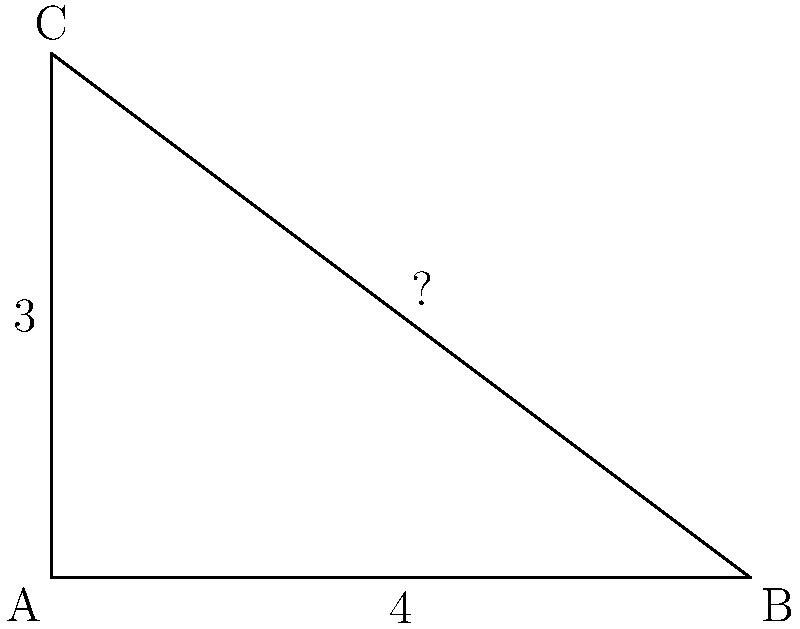In a mock interview scenario, you're discussing problem-solving skills with a job seeker. You present them with a right-angled triangle ABC, where the length of side AB is 4 units and the length of side AC is 3 units. How would you guide them to calculate the length of the hypotenuse BC using the Pythagorean theorem? To find the length of the hypotenuse BC, we can guide the job seeker through the following steps:

1. Identify the Pythagorean theorem: $a^2 + b^2 = c^2$, where $c$ is the hypotenuse and $a$ and $b$ are the other two sides.

2. Assign the known values:
   $a = 3$ (length of AC)
   $b = 4$ (length of AB)
   $c = $ unknown (length of BC, the hypotenuse)

3. Substitute these values into the Pythagorean theorem:
   $3^2 + 4^2 = c^2$

4. Calculate the squares:
   $9 + 16 = c^2$

5. Add the left side:
   $25 = c^2$

6. Take the square root of both sides:
   $\sqrt{25} = c$

7. Simplify:
   $5 = c$

Therefore, the length of the hypotenuse BC is 5 units.
Answer: 5 units 